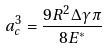Convert formula to latex. <formula><loc_0><loc_0><loc_500><loc_500>a _ { c } ^ { 3 } = \frac { 9 R ^ { 2 } \Delta \gamma \pi } { 8 E ^ { * } }</formula> 